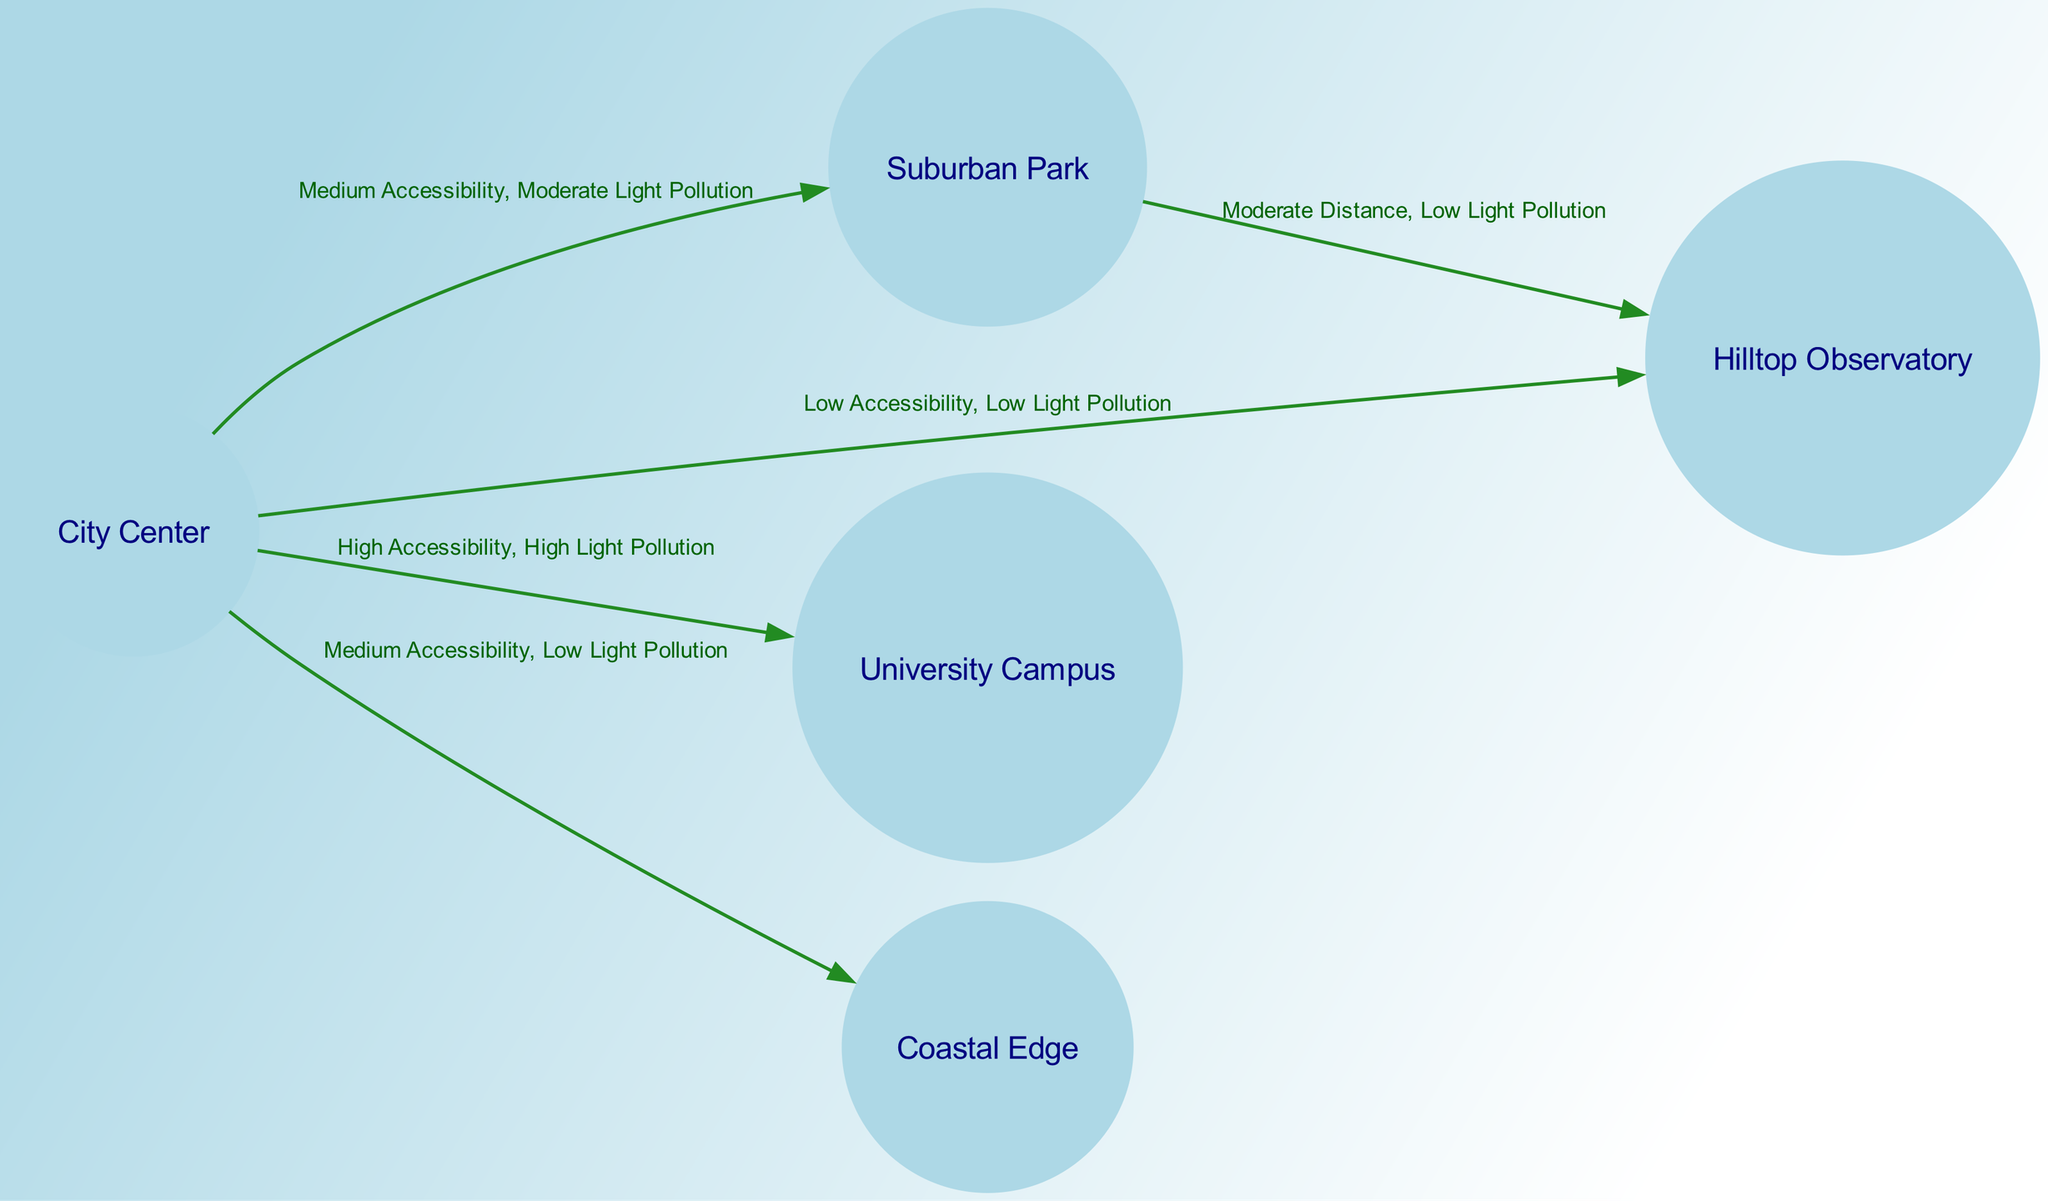What is the node with the lowest light pollution? The diagram shows that both "Hilltop Observatory" and "Coastal Edge" have low light pollution. However, to identify the specific node with the lowest light pollution, "Hilltop Observatory" is mentioned explicitly with "Low Light Pollution" in its connections.
Answer: Hilltop Observatory How many locations are connected directly to the City Center? From the diagram, the City Center has four edges leading out to other locations: Suburban Park, Hilltop Observatory, University Campus, and Coastal Edge. Therefore, it is connected directly to four locations.
Answer: Four Which location has the highest accessibility? The diagram indicates "University Campus" as having high accessibility, characterized by "High Accessibility, High Light Pollution" in the edge connecting it to the City Center.
Answer: University Campus What’s the relationship between Suburban Park and Hilltop Observatory? The diagram shows a direct connection labeled "Moderate Distance, Low Light Pollution" between Suburban Park and Hilltop Observatory, which highlights their proximity and the low pollution level.
Answer: Moderate Distance, Low Light Pollution Which location has medium accessibility and low light pollution? The diagram indicates that "Coastal Edge" has medium accessibility and low light pollution, as represented in the edge from City Center to Coastal Edge.
Answer: Coastal Edge What is the light pollution level of the University Campus? The direct connection from the City Center to University Campus states "High Accessibility, High Light Pollution," clearly indicating the light pollution level at that location.
Answer: High Light Pollution How many edges are there connecting all locations in the diagram? By counting the edges listed, we find there are a total of five edges connecting the nodes in the diagram.
Answer: Five What type of pollution is described in the connection from City Center to Hilltop Observatory? The connection from City Center to Hilltop Observatory is described as having "Low Light Pollution," which denotes the type of pollution associated with that specific edge.
Answer: Low Light Pollution Which two nodes have a direct connection representing low light pollution? The nodes "Hilltop Observatory" and "Coastal Edge" both have direct connections that represent low light pollution, as identified in their individual edges from the City Center.
Answer: Hilltop Observatory, Coastal Edge 